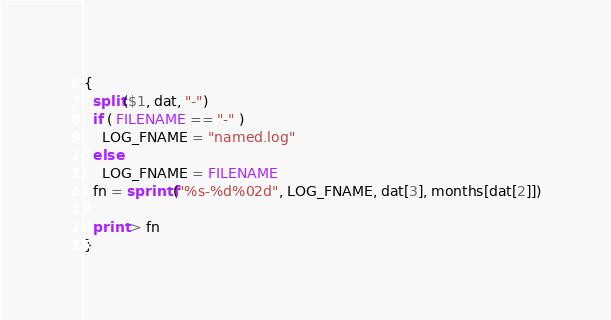<code> <loc_0><loc_0><loc_500><loc_500><_Awk_>{
  split($1, dat, "-")
  if ( FILENAME == "-" )
    LOG_FNAME = "named.log"
  else
    LOG_FNAME = FILENAME
  fn = sprintf("%s-%d%02d", LOG_FNAME, dat[3], months[dat[2]])

  print > fn
}

</code> 